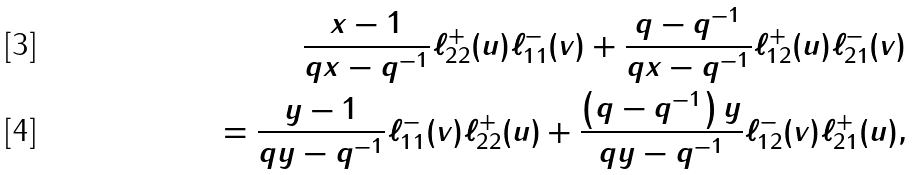<formula> <loc_0><loc_0><loc_500><loc_500>\frac { x - 1 } { q x - q ^ { - 1 } } \ell _ { 2 2 } ^ { + } ( u ) \ell _ { 1 1 } ^ { - } ( v ) + \frac { q - q ^ { - 1 } } { q x - q ^ { - 1 } } \ell _ { 1 2 } ^ { + } ( u ) \ell _ { 2 1 } ^ { - } ( v ) \\ = \frac { y - 1 } { q y - q ^ { - 1 } } \ell _ { 1 1 } ^ { - } ( v ) \ell _ { 2 2 } ^ { + } ( u ) + \frac { \left ( q - q ^ { - 1 } \right ) y } { q y - q ^ { - 1 } } \ell _ { 1 2 } ^ { - } ( v ) \ell _ { 2 1 } ^ { + } ( u ) ,</formula> 